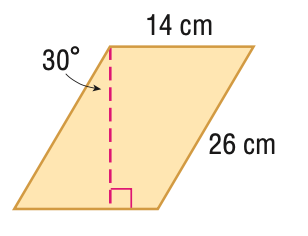Answer the mathemtical geometry problem and directly provide the correct option letter.
Question: Find the area of the parallelogram. Round to the nearest tenth if necessary.
Choices: A: 80.0 B: 157.6 C: 315.2 D: 364.0 C 